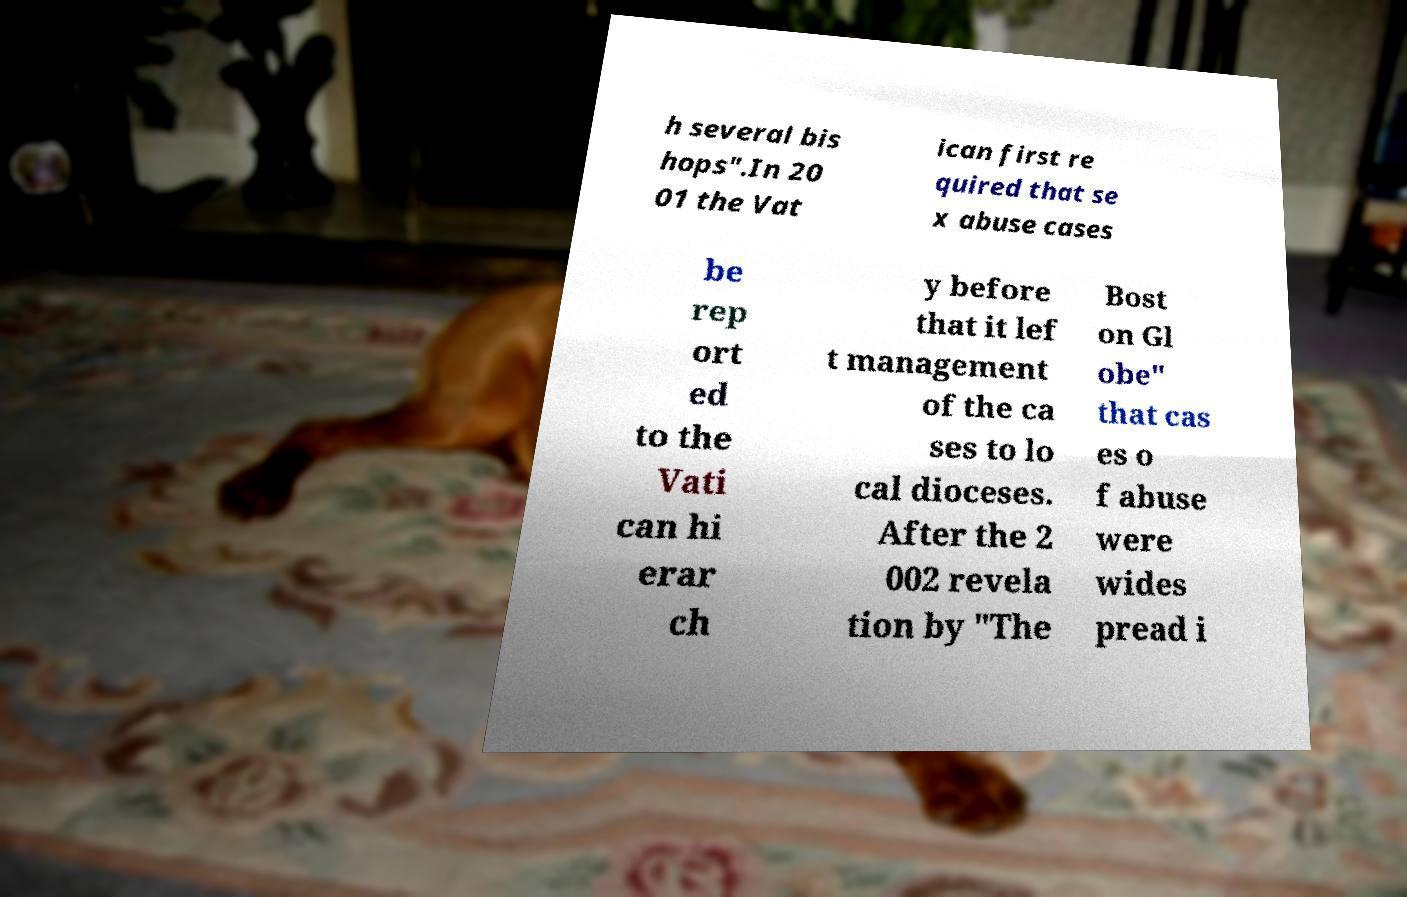Could you extract and type out the text from this image? h several bis hops".In 20 01 the Vat ican first re quired that se x abuse cases be rep ort ed to the Vati can hi erar ch y before that it lef t management of the ca ses to lo cal dioceses. After the 2 002 revela tion by "The Bost on Gl obe" that cas es o f abuse were wides pread i 